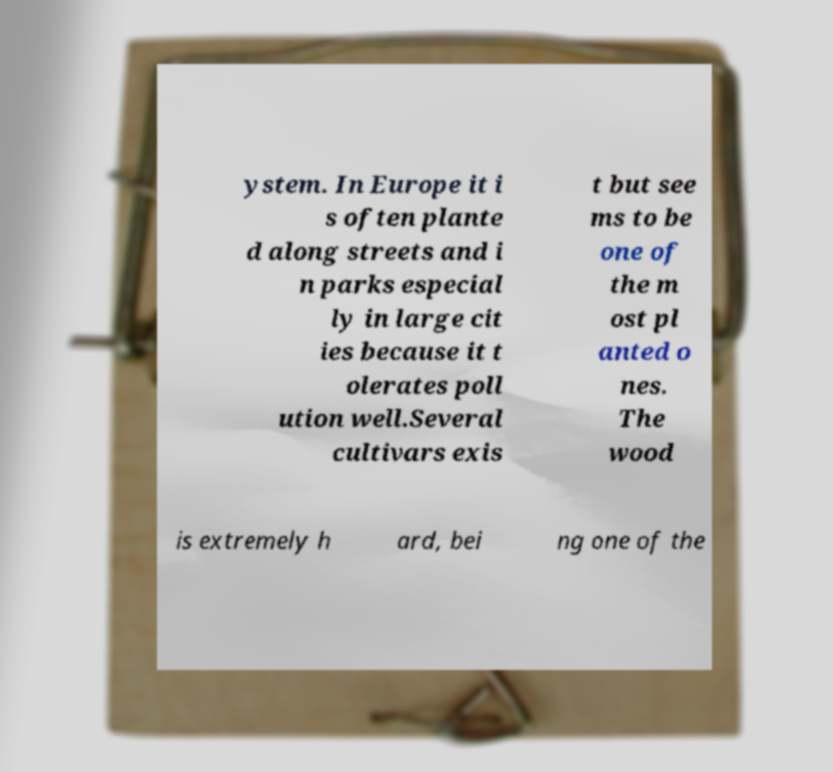Can you accurately transcribe the text from the provided image for me? ystem. In Europe it i s often plante d along streets and i n parks especial ly in large cit ies because it t olerates poll ution well.Several cultivars exis t but see ms to be one of the m ost pl anted o nes. The wood is extremely h ard, bei ng one of the 